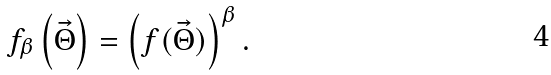Convert formula to latex. <formula><loc_0><loc_0><loc_500><loc_500>f _ { \beta } \left ( \vec { \Theta } \right ) = \left ( f ( \vec { \Theta } ) \right ) ^ { \beta } .</formula> 